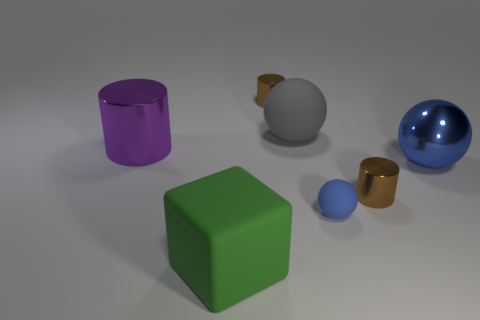Add 1 large purple shiny objects. How many objects exist? 8 Subtract all spheres. How many objects are left? 4 Add 2 big purple metal things. How many big purple metal things exist? 3 Subtract 1 gray spheres. How many objects are left? 6 Subtract all small blue metal cubes. Subtract all large cubes. How many objects are left? 6 Add 5 brown metallic cylinders. How many brown metallic cylinders are left? 7 